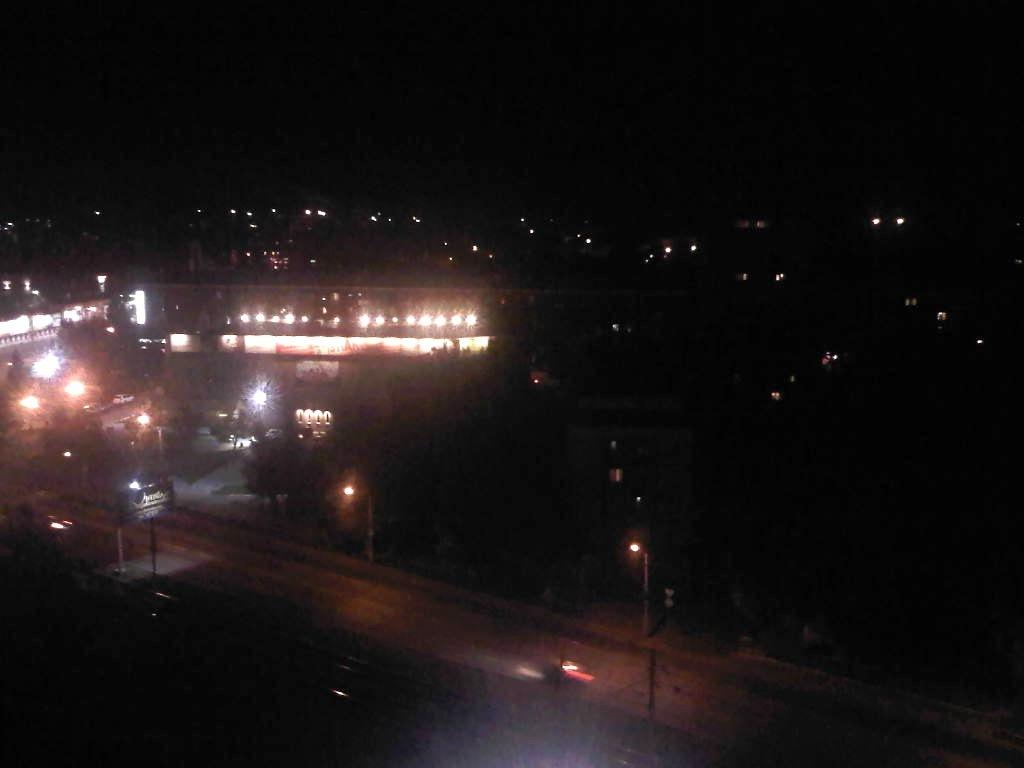What is the main subject of the image? The main subject of the image is a crowd. What other objects or structures can be seen in the image? There are light poles, vehicles, boards, and buildings visible in the image. What is the condition of the sky in the image? The sky is visible in the image, and it may have been taken during the night. How many people are needed to hold the kite in the image? There is no kite present in the image, so it is not possible to determine how many people would be needed to hold it. 